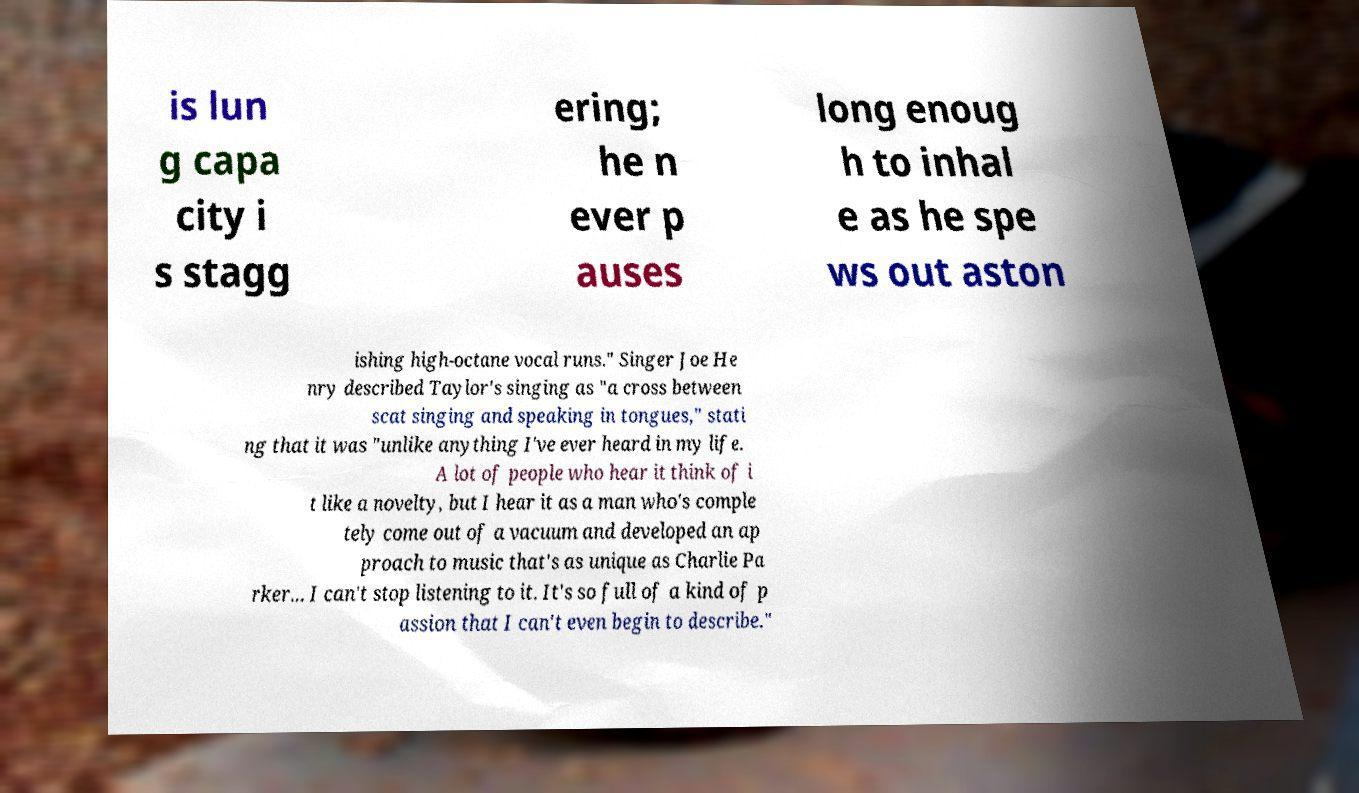Could you assist in decoding the text presented in this image and type it out clearly? is lun g capa city i s stagg ering; he n ever p auses long enoug h to inhal e as he spe ws out aston ishing high-octane vocal runs." Singer Joe He nry described Taylor's singing as "a cross between scat singing and speaking in tongues," stati ng that it was "unlike anything I've ever heard in my life. A lot of people who hear it think of i t like a novelty, but I hear it as a man who's comple tely come out of a vacuum and developed an ap proach to music that's as unique as Charlie Pa rker... I can't stop listening to it. It's so full of a kind of p assion that I can't even begin to describe." 